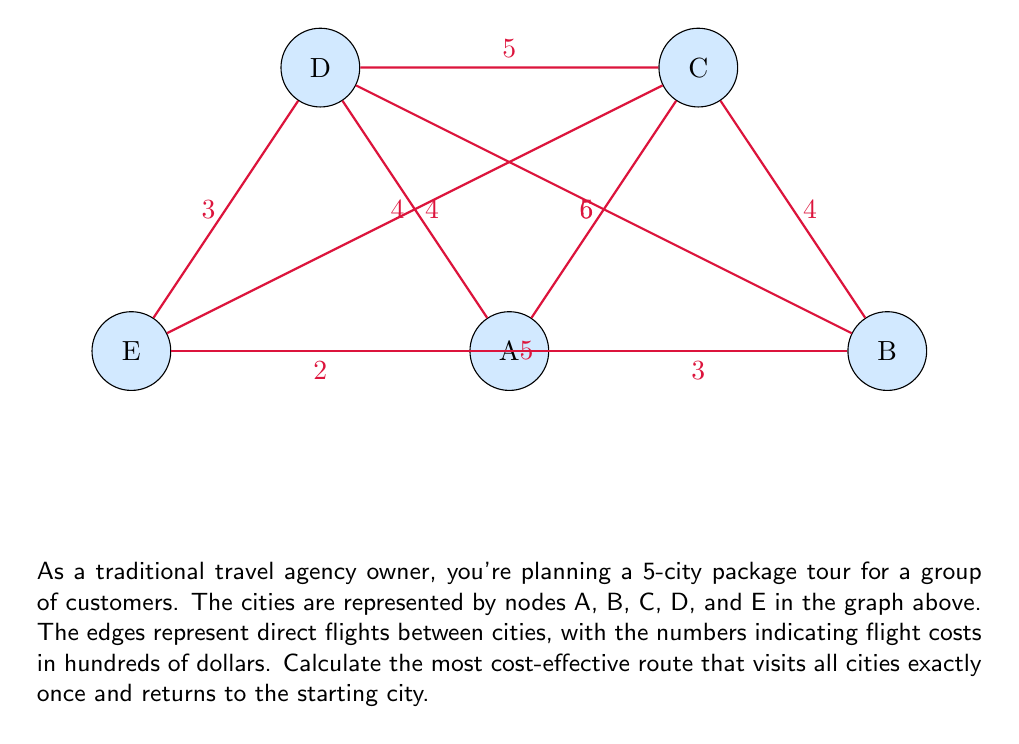Could you help me with this problem? To solve this problem, we'll use the Held-Karp algorithm, which is an exact method for solving the Traveling Salesman Problem (TSP). The steps are as follows:

1) Initialize:
   - Set $C(i,S) = \infty$ for all $i$ and $S$, where $i$ is a city and $S$ is a subset of cities.
   - For each city $j \neq 1$, set $C(j,\{1,j\}) = d_{1j}$, where $d_{1j}$ is the distance from city 1 to city j.

2) For $s = 3$ to $n$:
   For all subsets $S$ of size $s$ that include city 1:
     For all $j \in S, j \neq 1$:
       $C(j,S) = \min_{i \in S, i \neq j} [C(i,S-\{j\}) + d_{ij}]$

3) Return $\min_{j \neq 1} [C(j,\{1,2,\ldots,n\}) + d_{j1}]$

Let's apply this to our problem:

1) Initialize:
   $C(B,\{A,B\}) = 3$
   $C(C,\{A,C\}) = 5$
   $C(D,\{A,D\}) = 4$
   $C(E,\{A,E\}) = 2$

2) For subsets of size 3:
   $C(B,\{A,B,C\}) = \min[C(C,\{A,C\}) + d_{BC}] = 5 + 4 = 9$
   $C(C,\{A,B,C\}) = \min[C(B,\{A,B\}) + d_{BC}] = 3 + 4 = 7$
   ... (continue for all subsets of size 3)

3) For subsets of size 4:
   $C(B,\{A,B,C,D\}) = \min[C(C,\{A,C,D\}) + d_{BC}, C(D,\{A,C,D\}) + d_{BD}]$
   ... (continue for all subsets of size 4)

4) For the full set:
   $C(B,\{A,B,C,D,E\}) = \min[C(C,\{A,C,D,E\}) + d_{BC}, C(D,\{A,C,D,E\}) + d_{BD}, C(E,\{A,C,D,E\}) + d_{BE}]$
   ... (calculate for C, D, and E as well)

5) Return $\min[C(B,\{A,B,C,D,E\}) + d_{BA}, C(C,\{A,B,C,D,E\}) + d_{CA}, C(D,\{A,B,C,D,E\}) + d_{DA}, C(E,\{A,B,C,D,E\}) + d_{EA}]$

After completing all calculations, we find that the minimum cost is 17, corresponding to the route A-E-B-C-D-A.
Answer: 17 (route: A-E-B-C-D-A) 